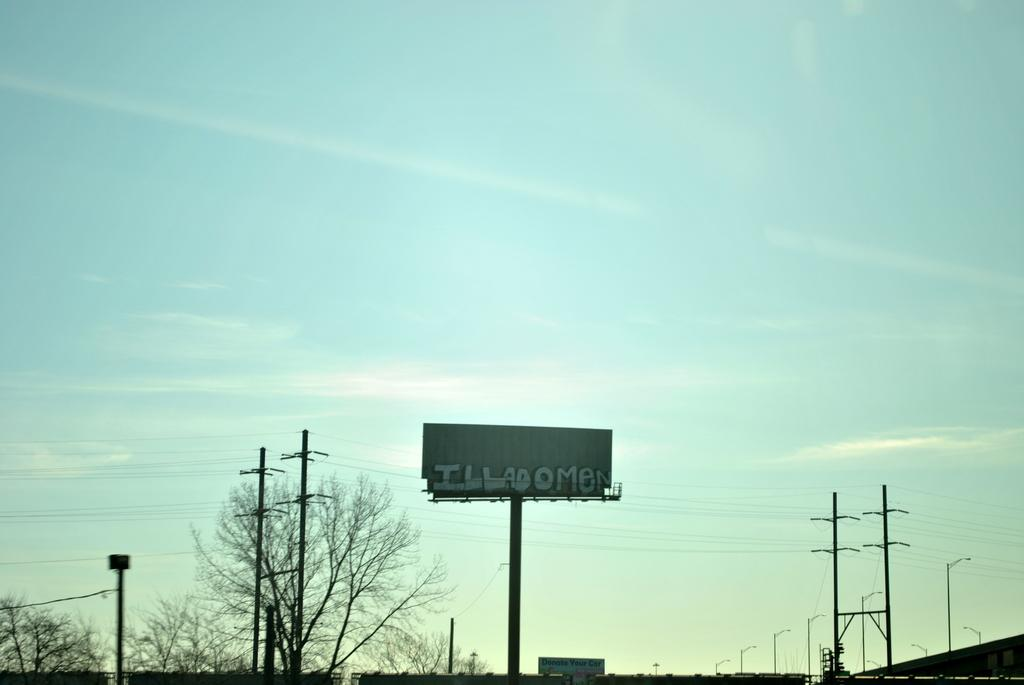Provide a one-sentence caption for the provided image. The back side of a high rise sign reads ILLADOMEN. 